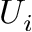Convert formula to latex. <formula><loc_0><loc_0><loc_500><loc_500>U _ { i }</formula> 